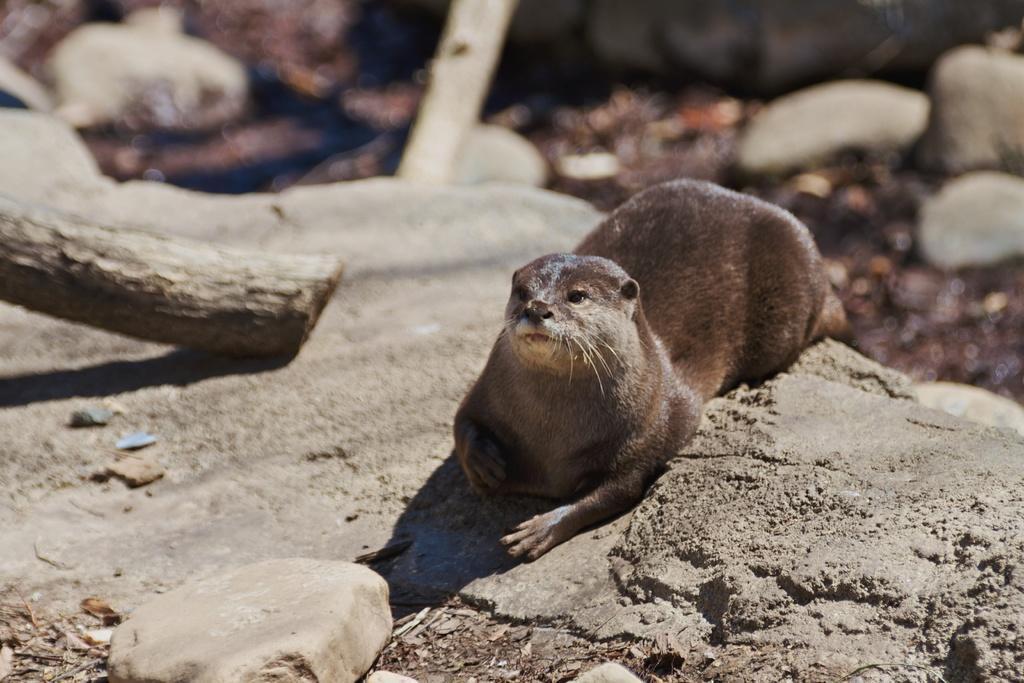How would you summarize this image in a sentence or two? In this image I can see an animal which is black, brown and cream in color is on the rocky surface. I can see a wooden log and the blurry background in which I can see few rocks. 